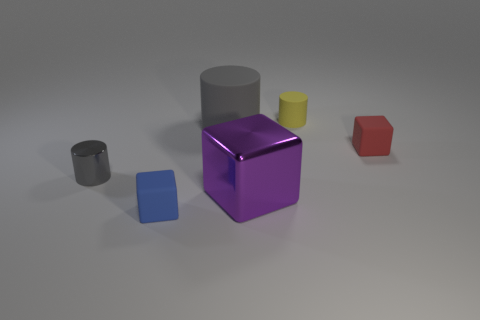Add 2 green metallic spheres. How many objects exist? 8 Add 1 gray shiny objects. How many gray shiny objects exist? 2 Subtract 0 red cylinders. How many objects are left? 6 Subtract all tiny yellow cylinders. Subtract all small cyan cylinders. How many objects are left? 5 Add 3 blue matte cubes. How many blue matte cubes are left? 4 